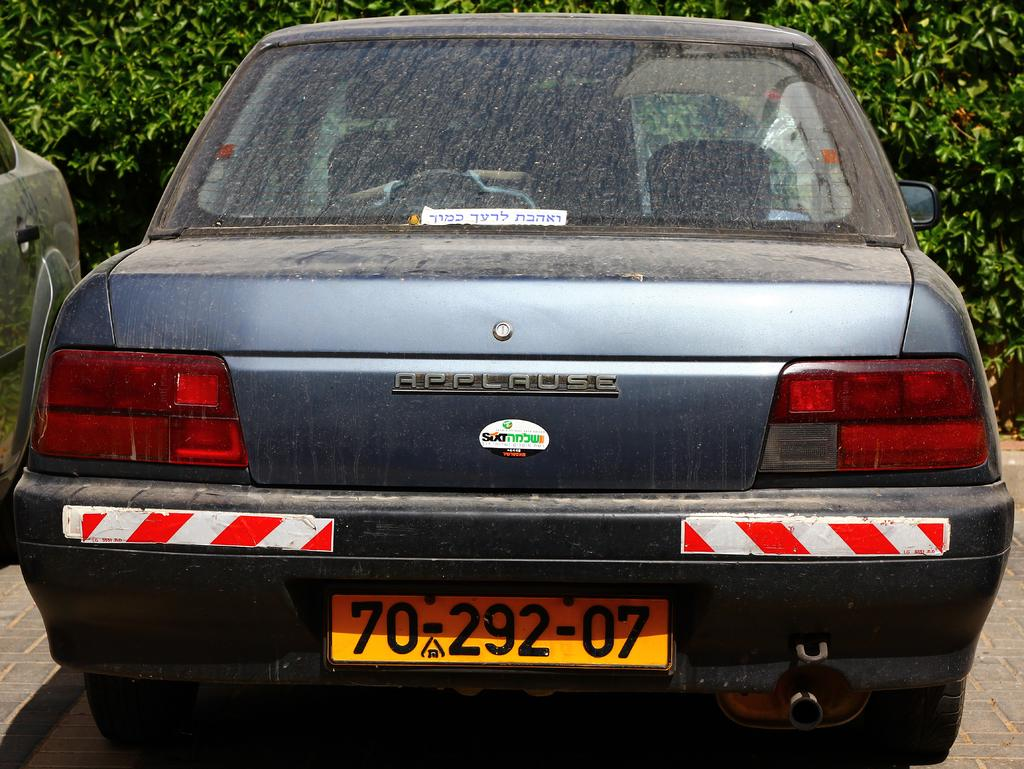<image>
Present a compact description of the photo's key features. An older model Applause car, with license plate 70-292-07, is parked in the parking lot. 